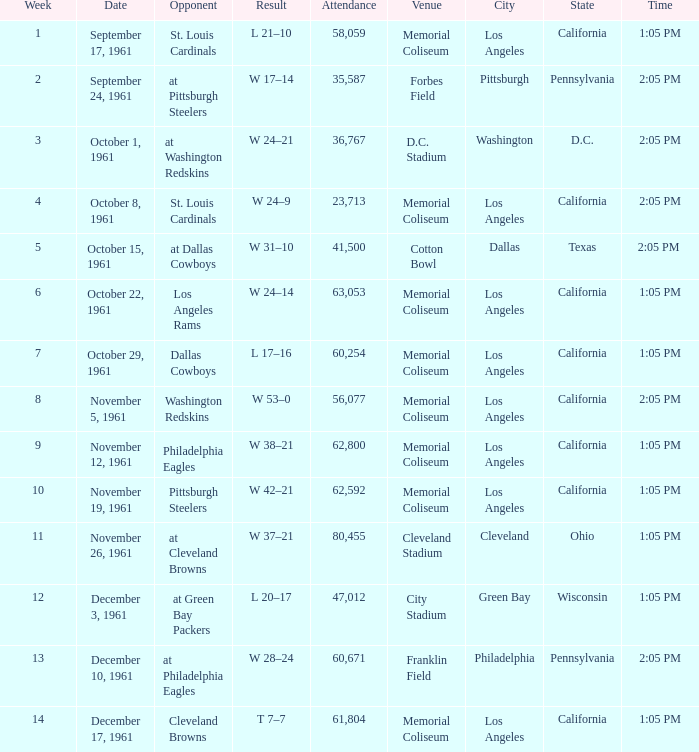Which Attendance has a Date of november 19, 1961? 62592.0. 